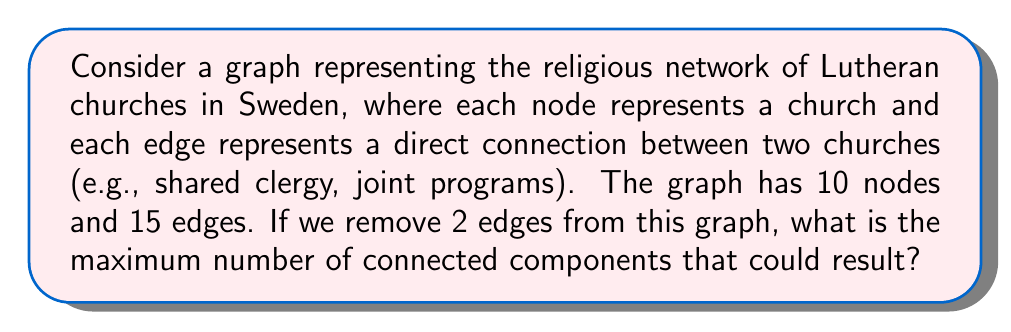Could you help me with this problem? To solve this problem, we need to understand a few key concepts from graph theory:

1. Connected components: These are subgraphs in which any two vertices are connected to each other by paths.

2. Tree: A connected graph with no cycles. For a tree with $n$ nodes, there are exactly $n-1$ edges.

3. Connectivity: The minimum number of edges that need to be removed to disconnect the graph.

Now, let's approach the problem step-by-step:

1. We start with a graph $G$ that has 10 nodes and 15 edges.

2. The maximum number of connected components will occur when we remove edges that are most crucial for connectivity.

3. In the worst case scenario (for connectivity), our graph would be barely connected before removing any edges. This means it would be a tree plus some additional edges.

4. A tree with 10 nodes would have 9 edges. Our graph has 6 additional edges (15 - 9 = 6).

5. Each of these 6 additional edges creates a cycle in the graph.

6. Removing one edge from a cycle doesn't create a new connected component.

7. Therefore, to maximize the number of components, we should remove edges that are not part of these cycles, i.e., edges that are part of the underlying tree structure.

8. Removing one such edge splits the graph into two components.

9. Removing a second such edge can at most split one of these components into two.

Therefore, the maximum number of connected components after removing 2 edges is 3.

This scenario would occur if the original graph was structured in such a way that it had two "bridge" edges, whose removal would separate the graph into three parts.
Answer: 3 connected components 